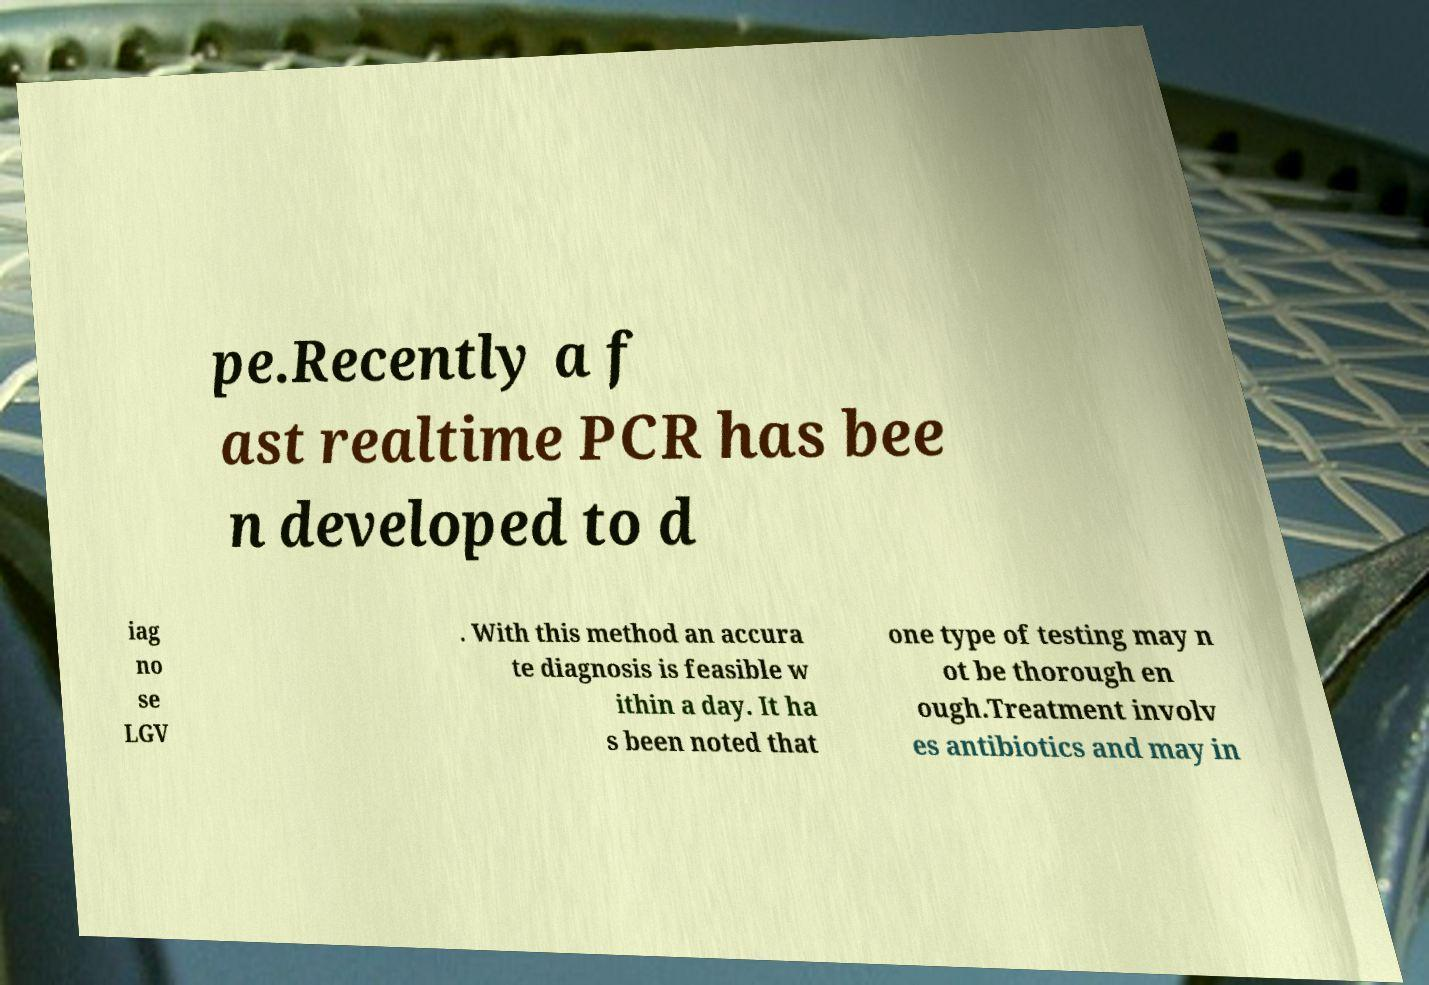Can you read and provide the text displayed in the image?This photo seems to have some interesting text. Can you extract and type it out for me? pe.Recently a f ast realtime PCR has bee n developed to d iag no se LGV . With this method an accura te diagnosis is feasible w ithin a day. It ha s been noted that one type of testing may n ot be thorough en ough.Treatment involv es antibiotics and may in 